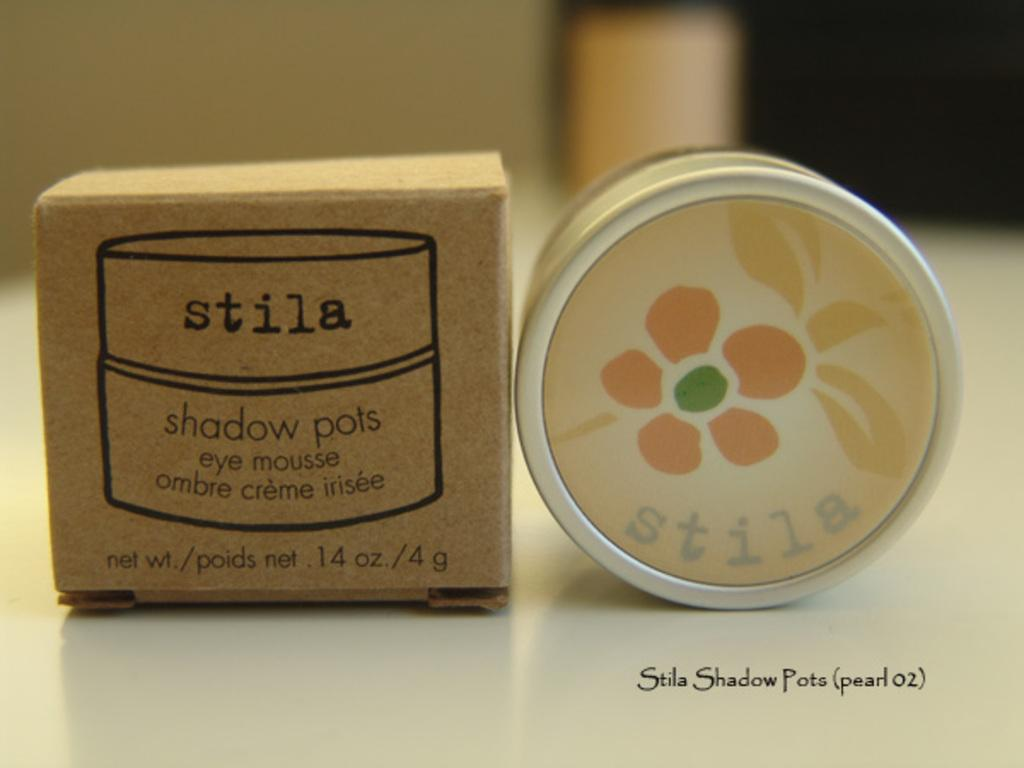<image>
Write a terse but informative summary of the picture. a brown box that says stila at the top of it 